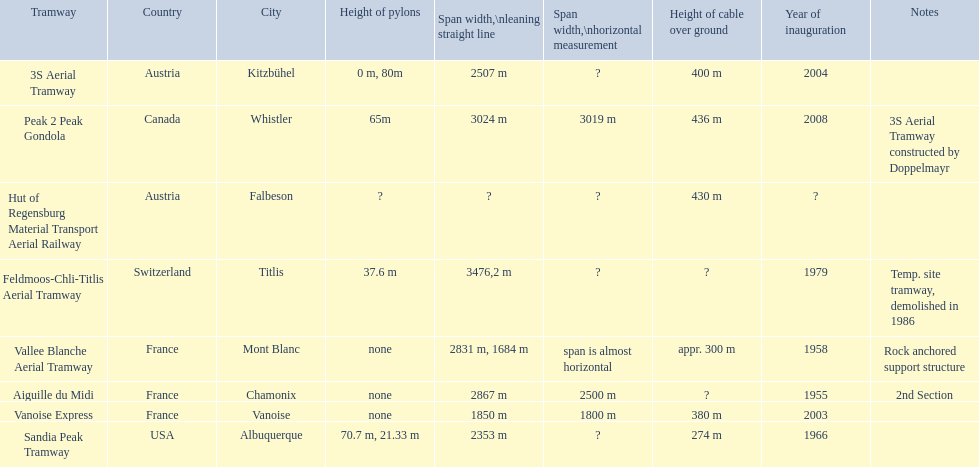Could you parse the entire table? {'header': ['Tramway', 'Country', 'City', 'Height of pylons', 'Span\xa0width,\\nleaning straight line', 'Span width,\\nhorizontal measurement', 'Height of cable over ground', 'Year of inauguration', 'Notes'], 'rows': [['3S Aerial Tramway', 'Austria', 'Kitzbühel', '0 m, 80m', '2507 m', '?', '400 m', '2004', ''], ['Peak 2 Peak Gondola', 'Canada', 'Whistler', '65m', '3024 m', '3019 m', '436 m', '2008', '3S Aerial Tramway constructed by Doppelmayr'], ['Hut of Regensburg Material Transport Aerial Railway', 'Austria', 'Falbeson', '?', '?', '?', '430 m', '?', ''], ['Feldmoos-Chli-Titlis Aerial Tramway', 'Switzerland', 'Titlis', '37.6 m', '3476,2 m', '?', '?', '1979', 'Temp. site tramway, demolished in 1986'], ['Vallee Blanche Aerial Tramway', 'France', 'Mont Blanc', 'none', '2831 m, 1684 m', 'span is almost horizontal', 'appr. 300 m', '1958', 'Rock anchored support structure'], ['Aiguille du Midi', 'France', 'Chamonix', 'none', '2867 m', '2500 m', '?', '1955', '2nd Section'], ['Vanoise Express', 'France', 'Vanoise', 'none', '1850 m', '1800 m', '380 m', '2003', ''], ['Sandia Peak Tramway', 'USA', 'Albuquerque', '70.7 m, 21.33 m', '2353 m', '?', '274 m', '1966', '']]} How much further is the peak 2 peak gondola in comparison to the 32 aerial tramway? 517. 